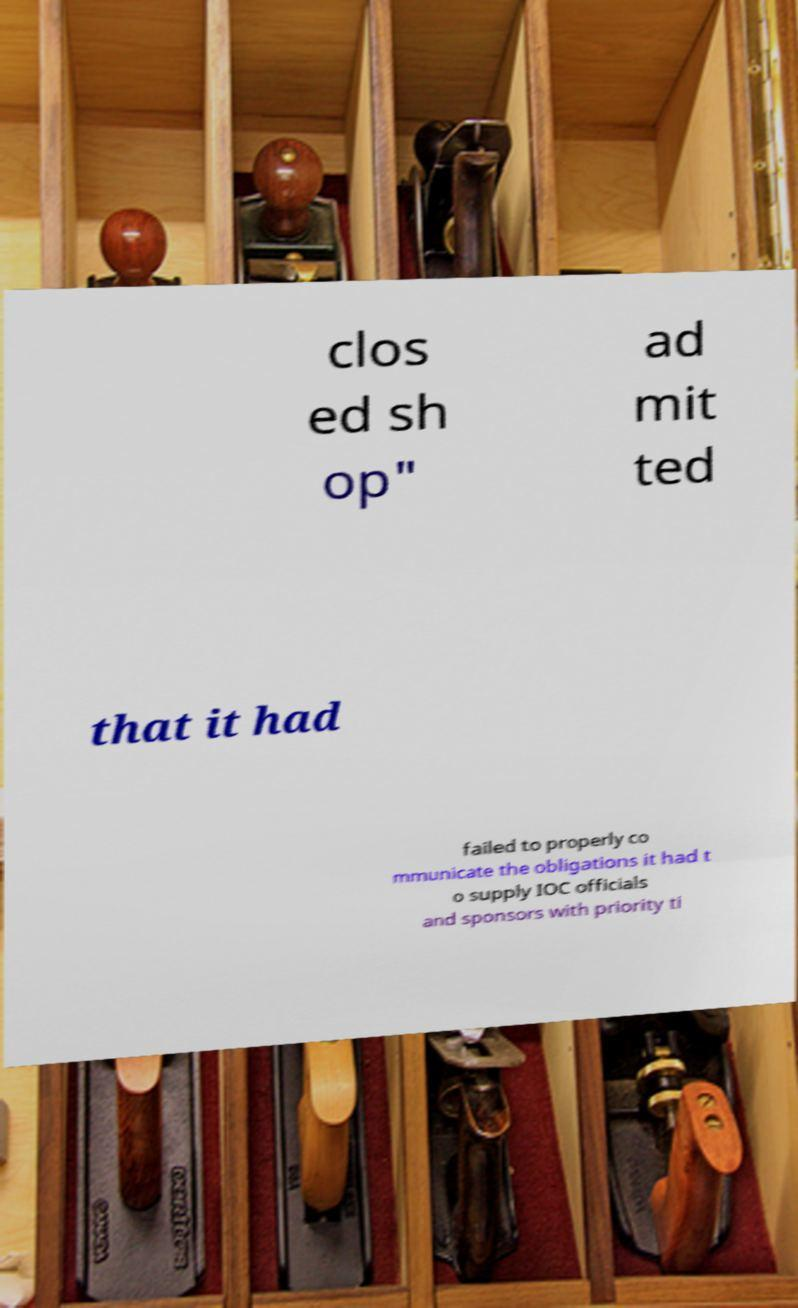What messages or text are displayed in this image? I need them in a readable, typed format. clos ed sh op" ad mit ted that it had failed to properly co mmunicate the obligations it had t o supply IOC officials and sponsors with priority ti 